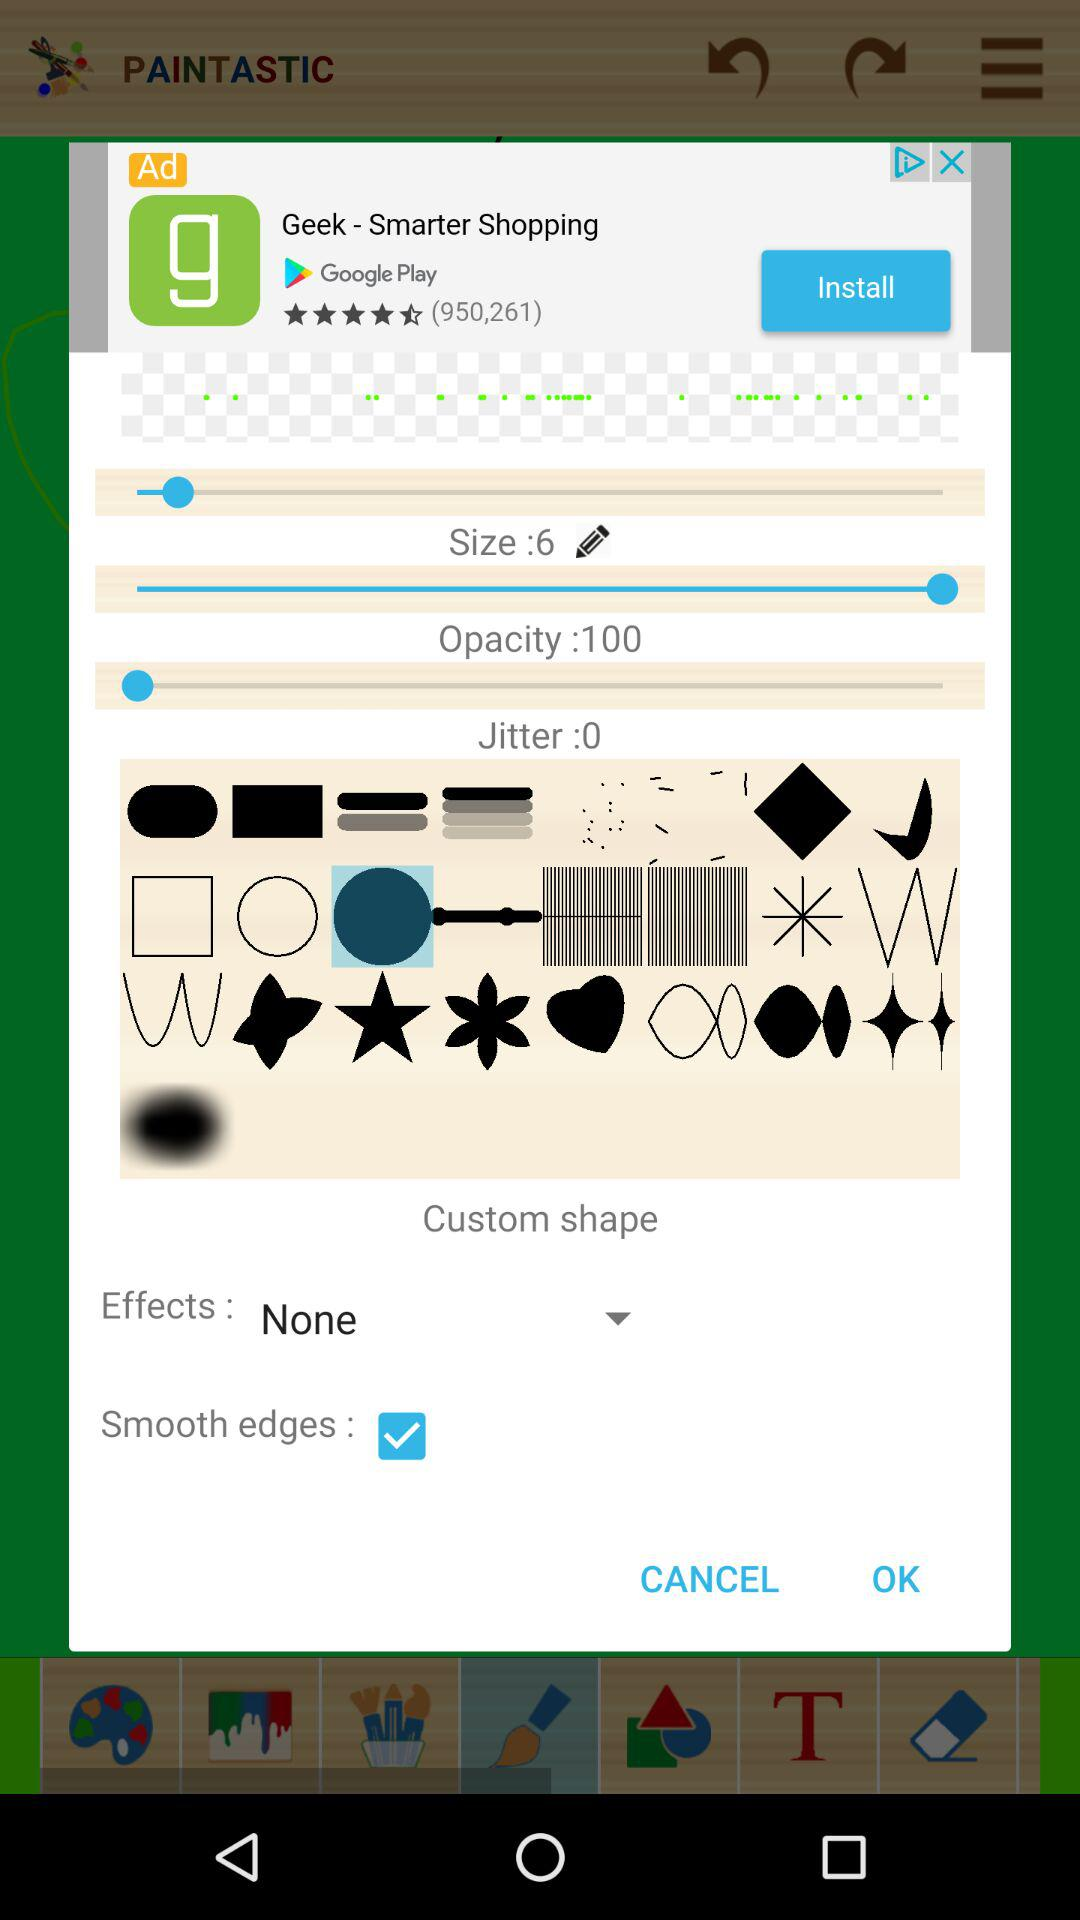What is the jitter? The jitter is 0. 